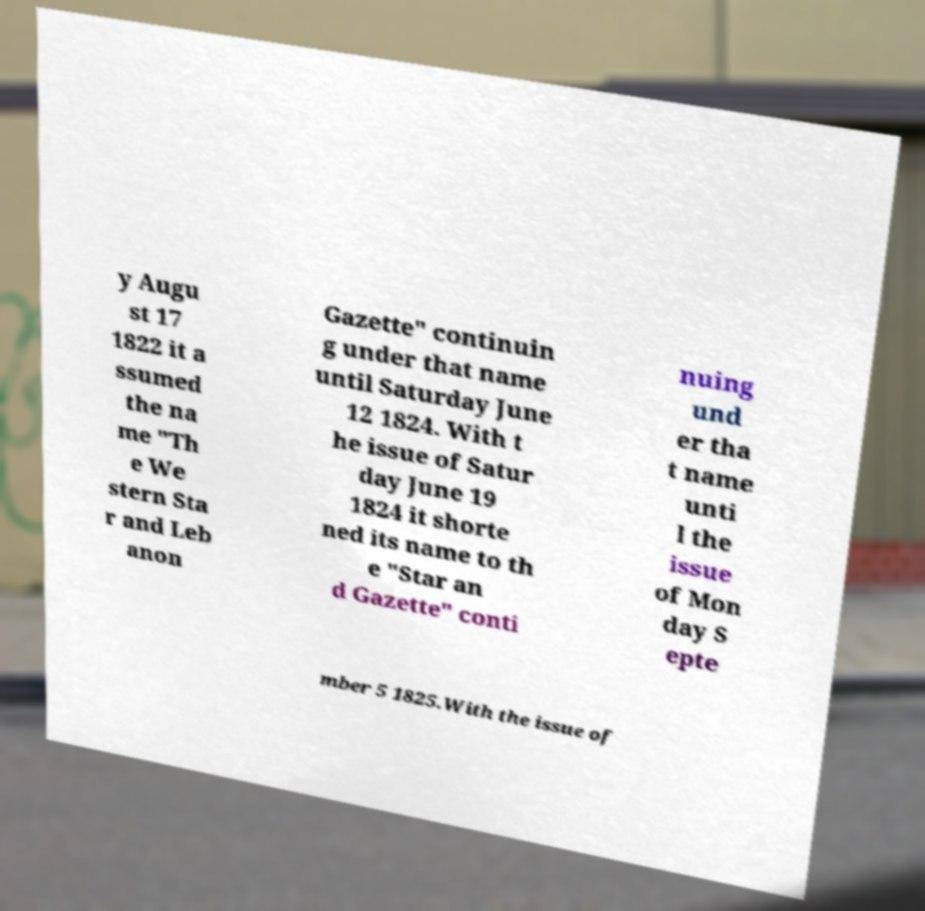Can you read and provide the text displayed in the image?This photo seems to have some interesting text. Can you extract and type it out for me? y Augu st 17 1822 it a ssumed the na me "Th e We stern Sta r and Leb anon Gazette" continuin g under that name until Saturday June 12 1824. With t he issue of Satur day June 19 1824 it shorte ned its name to th e "Star an d Gazette" conti nuing und er tha t name unti l the issue of Mon day S epte mber 5 1825.With the issue of 